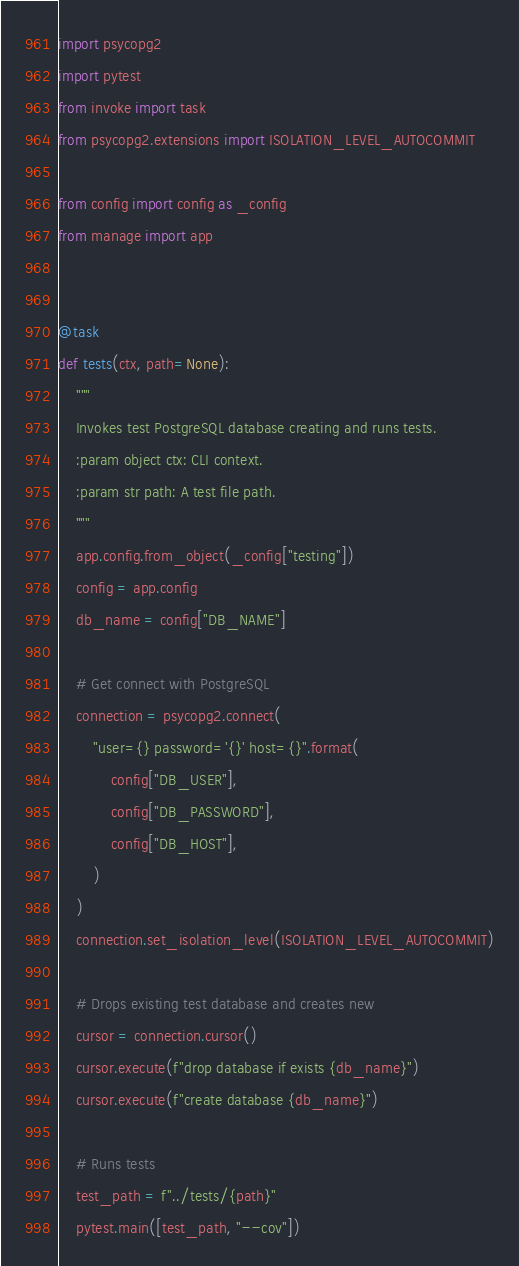Convert code to text. <code><loc_0><loc_0><loc_500><loc_500><_Python_>import psycopg2
import pytest
from invoke import task
from psycopg2.extensions import ISOLATION_LEVEL_AUTOCOMMIT

from config import config as _config
from manage import app


@task
def tests(ctx, path=None):
    """
    Invokes test PostgreSQL database creating and runs tests.
    :param object ctx: CLI context.
    :param str path: A test file path.
    """
    app.config.from_object(_config["testing"])
    config = app.config
    db_name = config["DB_NAME"]

    # Get connect with PostgreSQL
    connection = psycopg2.connect(
        "user={} password='{}' host={}".format(
            config["DB_USER"],
            config["DB_PASSWORD"],
            config["DB_HOST"],
        )
    )
    connection.set_isolation_level(ISOLATION_LEVEL_AUTOCOMMIT)

    # Drops existing test database and creates new
    cursor = connection.cursor()
    cursor.execute(f"drop database if exists {db_name}")
    cursor.execute(f"create database {db_name}")

    # Runs tests
    test_path = f"../tests/{path}"
    pytest.main([test_path, "--cov"])
</code> 